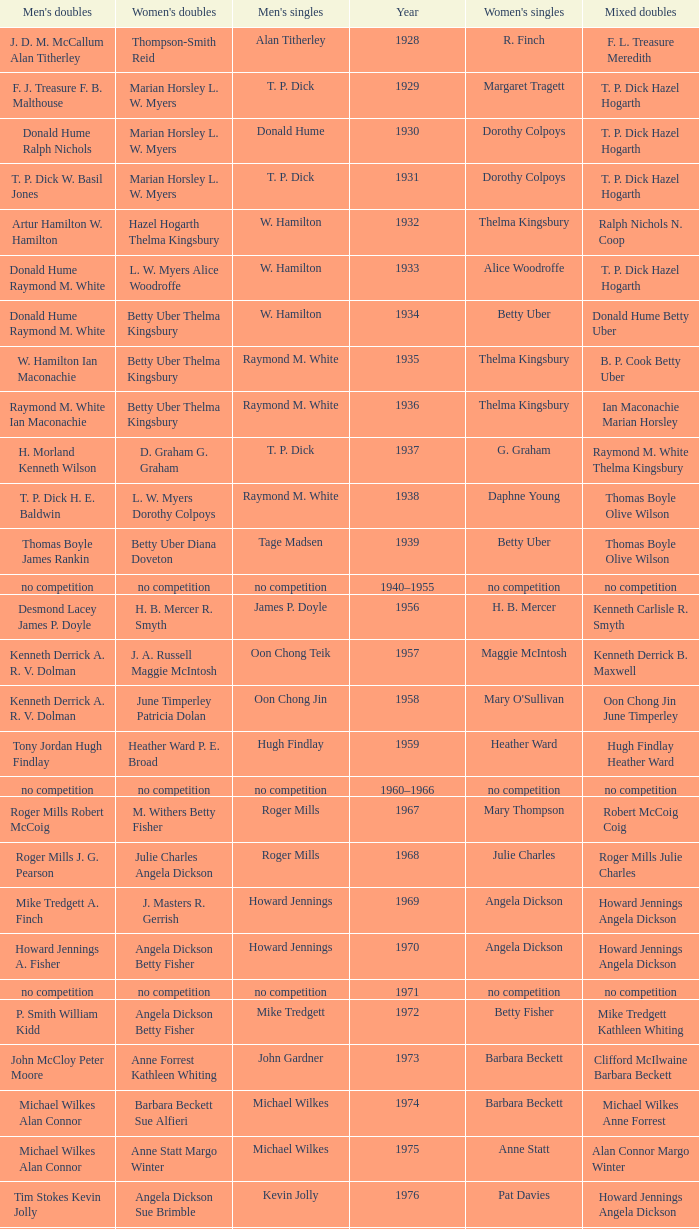Who won the Women's singles, in the year that Raymond M. White won the Men's singles and that W. Hamilton Ian Maconachie won the Men's doubles? Thelma Kingsbury. 